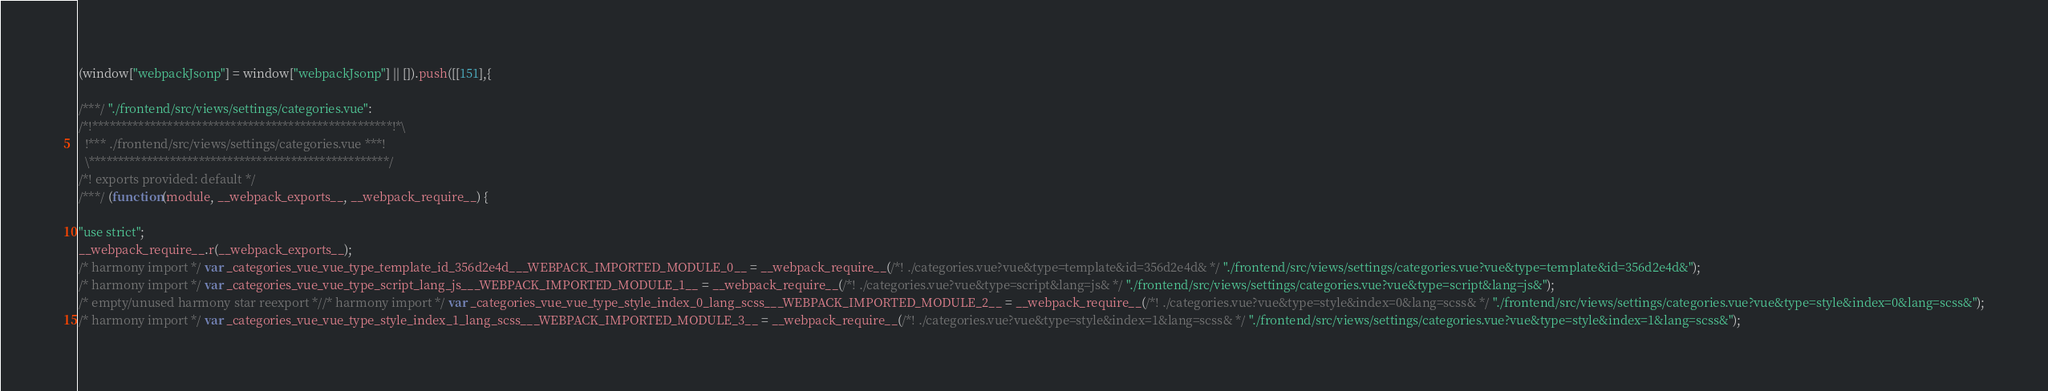<code> <loc_0><loc_0><loc_500><loc_500><_JavaScript_>(window["webpackJsonp"] = window["webpackJsonp"] || []).push([[151],{

/***/ "./frontend/src/views/settings/categories.vue":
/*!****************************************************!*\
  !*** ./frontend/src/views/settings/categories.vue ***!
  \****************************************************/
/*! exports provided: default */
/***/ (function(module, __webpack_exports__, __webpack_require__) {

"use strict";
__webpack_require__.r(__webpack_exports__);
/* harmony import */ var _categories_vue_vue_type_template_id_356d2e4d___WEBPACK_IMPORTED_MODULE_0__ = __webpack_require__(/*! ./categories.vue?vue&type=template&id=356d2e4d& */ "./frontend/src/views/settings/categories.vue?vue&type=template&id=356d2e4d&");
/* harmony import */ var _categories_vue_vue_type_script_lang_js___WEBPACK_IMPORTED_MODULE_1__ = __webpack_require__(/*! ./categories.vue?vue&type=script&lang=js& */ "./frontend/src/views/settings/categories.vue?vue&type=script&lang=js&");
/* empty/unused harmony star reexport *//* harmony import */ var _categories_vue_vue_type_style_index_0_lang_scss___WEBPACK_IMPORTED_MODULE_2__ = __webpack_require__(/*! ./categories.vue?vue&type=style&index=0&lang=scss& */ "./frontend/src/views/settings/categories.vue?vue&type=style&index=0&lang=scss&");
/* harmony import */ var _categories_vue_vue_type_style_index_1_lang_scss___WEBPACK_IMPORTED_MODULE_3__ = __webpack_require__(/*! ./categories.vue?vue&type=style&index=1&lang=scss& */ "./frontend/src/views/settings/categories.vue?vue&type=style&index=1&lang=scss&");</code> 